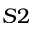<formula> <loc_0><loc_0><loc_500><loc_500>S 2</formula> 